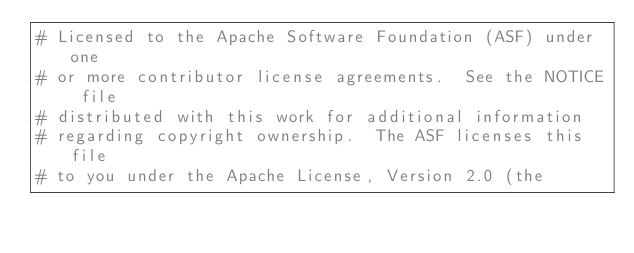<code> <loc_0><loc_0><loc_500><loc_500><_Python_># Licensed to the Apache Software Foundation (ASF) under one
# or more contributor license agreements.  See the NOTICE file
# distributed with this work for additional information
# regarding copyright ownership.  The ASF licenses this file
# to you under the Apache License, Version 2.0 (the</code> 